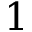Convert formula to latex. <formula><loc_0><loc_0><loc_500><loc_500>1</formula> 